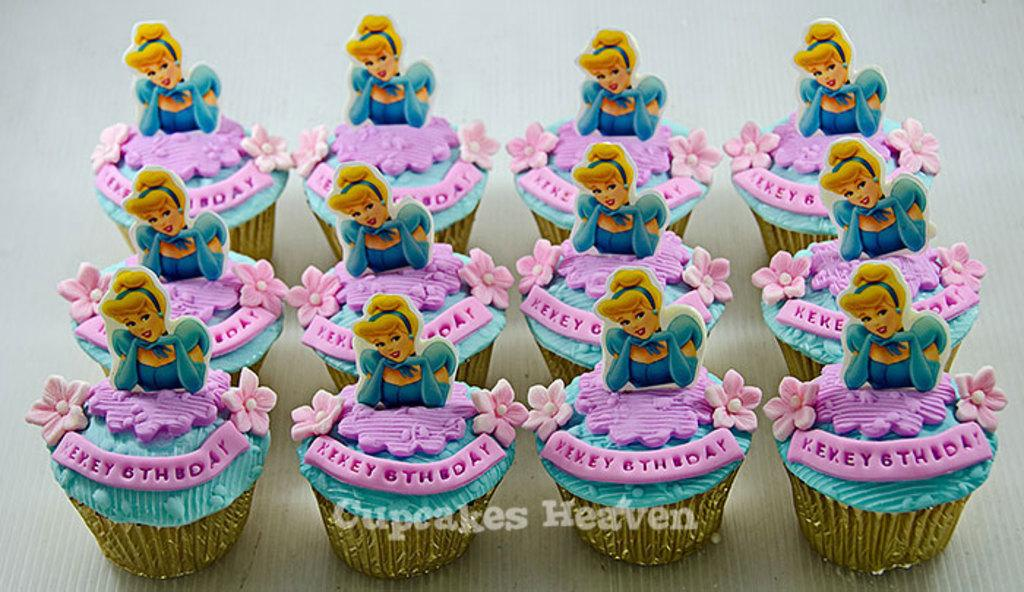What type of food is visible in the image? There are cupcakes in the image. What design or decoration is featured on the cupcakes? The cupcakes have cartoon images on them. What type of haircut is the yak getting in the image? There is no yak or any indication of a haircut in the image; it features cupcakes with cartoon images on them. 